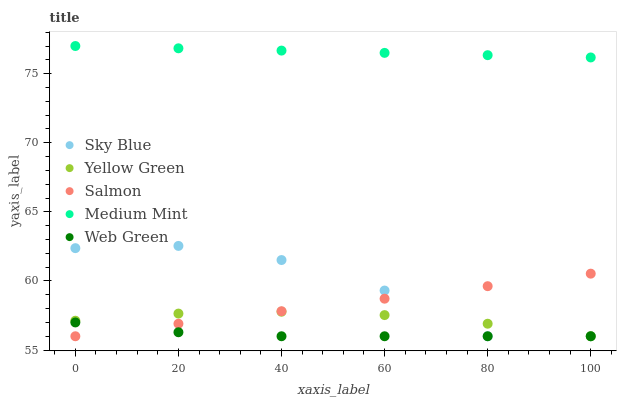Does Web Green have the minimum area under the curve?
Answer yes or no. Yes. Does Medium Mint have the maximum area under the curve?
Answer yes or no. Yes. Does Sky Blue have the minimum area under the curve?
Answer yes or no. No. Does Sky Blue have the maximum area under the curve?
Answer yes or no. No. Is Salmon the smoothest?
Answer yes or no. Yes. Is Sky Blue the roughest?
Answer yes or no. Yes. Is Sky Blue the smoothest?
Answer yes or no. No. Is Salmon the roughest?
Answer yes or no. No. Does Sky Blue have the lowest value?
Answer yes or no. Yes. Does Medium Mint have the highest value?
Answer yes or no. Yes. Does Sky Blue have the highest value?
Answer yes or no. No. Is Yellow Green less than Medium Mint?
Answer yes or no. Yes. Is Medium Mint greater than Web Green?
Answer yes or no. Yes. Does Salmon intersect Yellow Green?
Answer yes or no. Yes. Is Salmon less than Yellow Green?
Answer yes or no. No. Is Salmon greater than Yellow Green?
Answer yes or no. No. Does Yellow Green intersect Medium Mint?
Answer yes or no. No. 